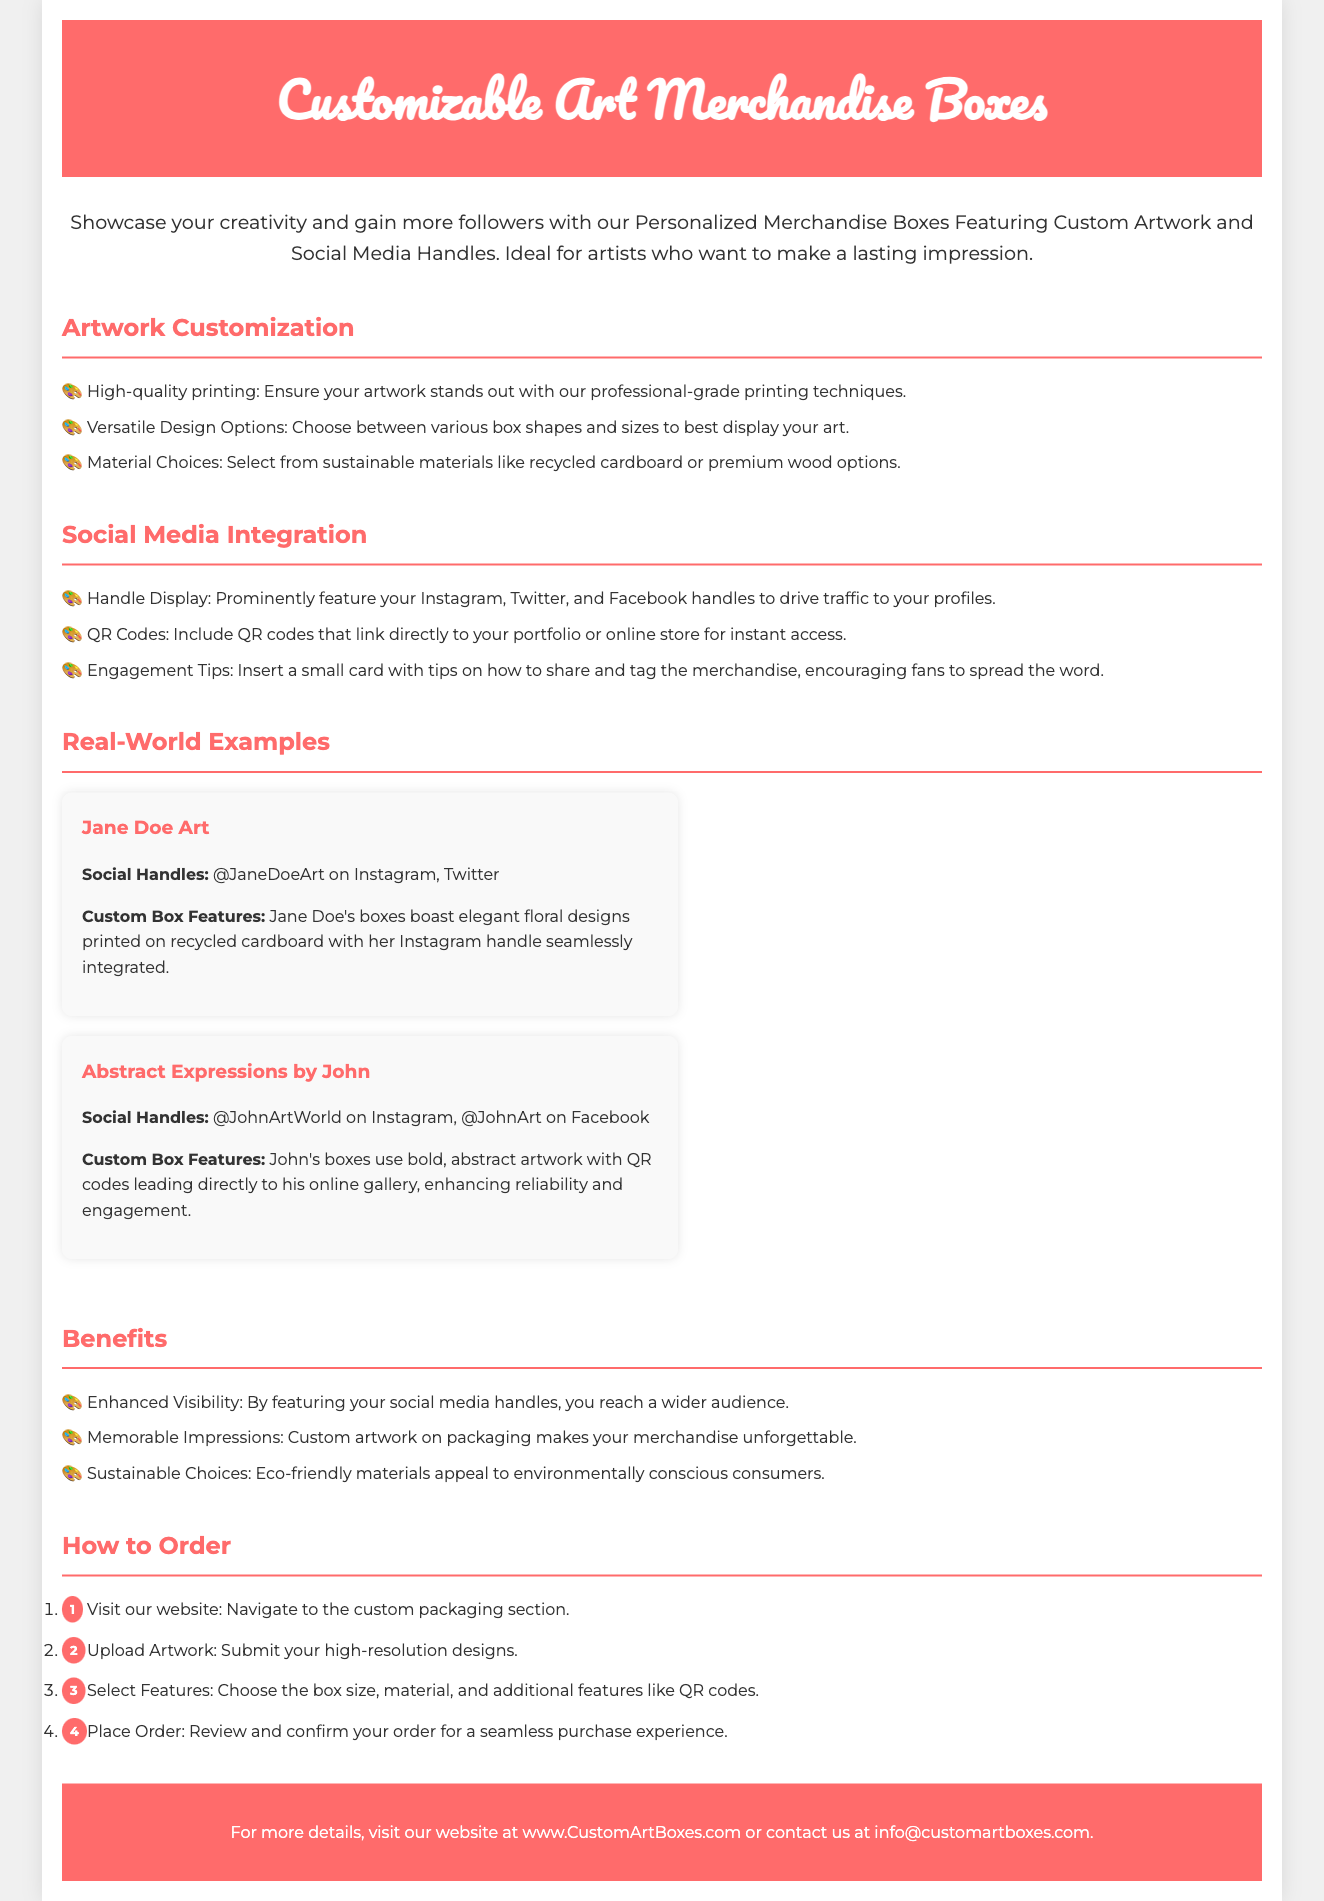What is the title of the document? The title is reflected in the main header of the document, which is "Customizable Art Merchandise Boxes."
Answer: Customizable Art Merchandise Boxes What is the main purpose of the merchandise boxes? The purpose is outlined in the introductory paragraph, highlighting the goal of showcasing creativity and gaining followers.
Answer: Showcase creativity and gain more followers What types of materials can be selected for the boxes? The document lists material choices in the Artwork Customization section, specifically mentioning options.
Answer: Recycled cardboard or premium wood How many real-world examples are provided in the document? The document includes a section dedicated to showing examples along with descriptions.
Answer: Two What feature is mentioned to enhance social media engagement? The document discusses various features aimed at improving engagement through social media integration.
Answer: QR codes What is the first step to order the boxes? The steps to order are clearly numbered in the How to Order section of the document.
Answer: Visit our website What benefit is highlighted regarding the visibility of artists? The document emphasizes the benefits of social media handles for artists reaching a wider audience.
Answer: Enhanced Visibility Which artist's box features floral designs? The document provides specific names under real-world examples showcasing features of each artist's boxes.
Answer: Jane Doe Art What type of printing is used for the artwork on the boxes? The type of printing is mentioned in the Artwork Customization section, describing the quality used for the boxes.
Answer: High-quality printing 